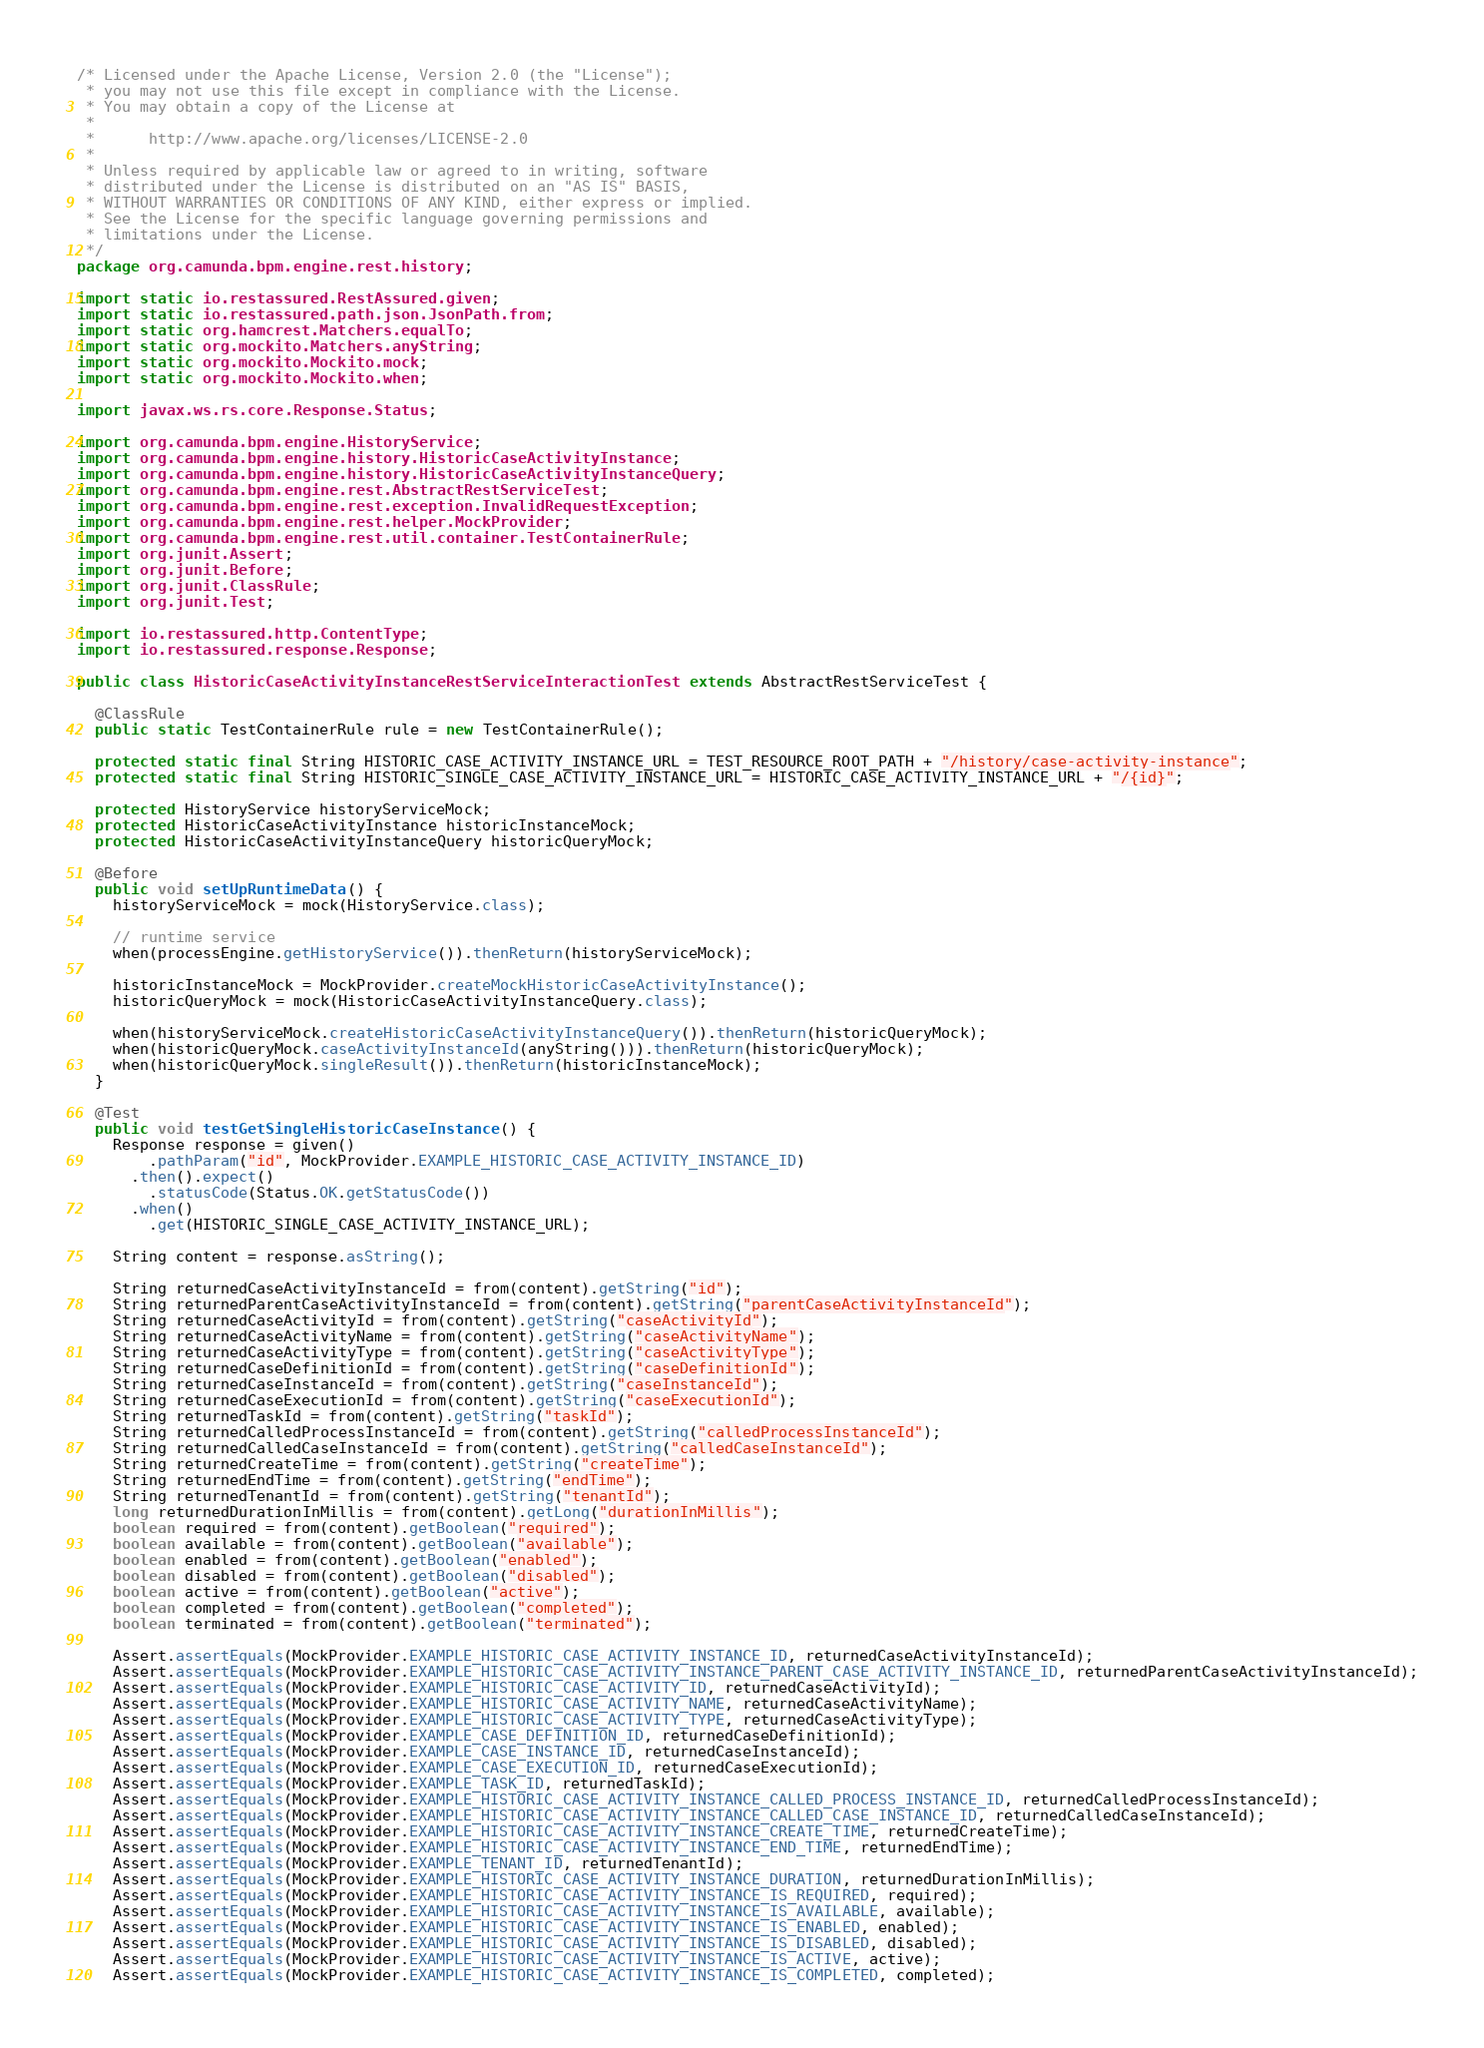<code> <loc_0><loc_0><loc_500><loc_500><_Java_>/* Licensed under the Apache License, Version 2.0 (the "License");
 * you may not use this file except in compliance with the License.
 * You may obtain a copy of the License at
 *
 *      http://www.apache.org/licenses/LICENSE-2.0
 *
 * Unless required by applicable law or agreed to in writing, software
 * distributed under the License is distributed on an "AS IS" BASIS,
 * WITHOUT WARRANTIES OR CONDITIONS OF ANY KIND, either express or implied.
 * See the License for the specific language governing permissions and
 * limitations under the License.
 */
package org.camunda.bpm.engine.rest.history;

import static io.restassured.RestAssured.given;
import static io.restassured.path.json.JsonPath.from;
import static org.hamcrest.Matchers.equalTo;
import static org.mockito.Matchers.anyString;
import static org.mockito.Mockito.mock;
import static org.mockito.Mockito.when;

import javax.ws.rs.core.Response.Status;

import org.camunda.bpm.engine.HistoryService;
import org.camunda.bpm.engine.history.HistoricCaseActivityInstance;
import org.camunda.bpm.engine.history.HistoricCaseActivityInstanceQuery;
import org.camunda.bpm.engine.rest.AbstractRestServiceTest;
import org.camunda.bpm.engine.rest.exception.InvalidRequestException;
import org.camunda.bpm.engine.rest.helper.MockProvider;
import org.camunda.bpm.engine.rest.util.container.TestContainerRule;
import org.junit.Assert;
import org.junit.Before;
import org.junit.ClassRule;
import org.junit.Test;

import io.restassured.http.ContentType;
import io.restassured.response.Response;

public class HistoricCaseActivityInstanceRestServiceInteractionTest extends AbstractRestServiceTest {

  @ClassRule
  public static TestContainerRule rule = new TestContainerRule();
  
  protected static final String HISTORIC_CASE_ACTIVITY_INSTANCE_URL = TEST_RESOURCE_ROOT_PATH + "/history/case-activity-instance";
  protected static final String HISTORIC_SINGLE_CASE_ACTIVITY_INSTANCE_URL = HISTORIC_CASE_ACTIVITY_INSTANCE_URL + "/{id}";

  protected HistoryService historyServiceMock;
  protected HistoricCaseActivityInstance historicInstanceMock;
  protected HistoricCaseActivityInstanceQuery historicQueryMock;

  @Before
  public void setUpRuntimeData() {
    historyServiceMock = mock(HistoryService.class);

    // runtime service
    when(processEngine.getHistoryService()).thenReturn(historyServiceMock);

    historicInstanceMock = MockProvider.createMockHistoricCaseActivityInstance();
    historicQueryMock = mock(HistoricCaseActivityInstanceQuery.class);

    when(historyServiceMock.createHistoricCaseActivityInstanceQuery()).thenReturn(historicQueryMock);
    when(historicQueryMock.caseActivityInstanceId(anyString())).thenReturn(historicQueryMock);
    when(historicQueryMock.singleResult()).thenReturn(historicInstanceMock);
  }

  @Test
  public void testGetSingleHistoricCaseInstance() {
    Response response = given()
        .pathParam("id", MockProvider.EXAMPLE_HISTORIC_CASE_ACTIVITY_INSTANCE_ID)
      .then().expect()
        .statusCode(Status.OK.getStatusCode())
      .when()
        .get(HISTORIC_SINGLE_CASE_ACTIVITY_INSTANCE_URL);

    String content = response.asString();

    String returnedCaseActivityInstanceId = from(content).getString("id");
    String returnedParentCaseActivityInstanceId = from(content).getString("parentCaseActivityInstanceId");
    String returnedCaseActivityId = from(content).getString("caseActivityId");
    String returnedCaseActivityName = from(content).getString("caseActivityName");
    String returnedCaseActivityType = from(content).getString("caseActivityType");
    String returnedCaseDefinitionId = from(content).getString("caseDefinitionId");
    String returnedCaseInstanceId = from(content).getString("caseInstanceId");
    String returnedCaseExecutionId = from(content).getString("caseExecutionId");
    String returnedTaskId = from(content).getString("taskId");
    String returnedCalledProcessInstanceId = from(content).getString("calledProcessInstanceId");
    String returnedCalledCaseInstanceId = from(content).getString("calledCaseInstanceId");
    String returnedCreateTime = from(content).getString("createTime");
    String returnedEndTime = from(content).getString("endTime");
    String returnedTenantId = from(content).getString("tenantId");
    long returnedDurationInMillis = from(content).getLong("durationInMillis");
    boolean required = from(content).getBoolean("required");
    boolean available = from(content).getBoolean("available");
    boolean enabled = from(content).getBoolean("enabled");
    boolean disabled = from(content).getBoolean("disabled");
    boolean active = from(content).getBoolean("active");
    boolean completed = from(content).getBoolean("completed");
    boolean terminated = from(content).getBoolean("terminated");

    Assert.assertEquals(MockProvider.EXAMPLE_HISTORIC_CASE_ACTIVITY_INSTANCE_ID, returnedCaseActivityInstanceId);
    Assert.assertEquals(MockProvider.EXAMPLE_HISTORIC_CASE_ACTIVITY_INSTANCE_PARENT_CASE_ACTIVITY_INSTANCE_ID, returnedParentCaseActivityInstanceId);
    Assert.assertEquals(MockProvider.EXAMPLE_HISTORIC_CASE_ACTIVITY_ID, returnedCaseActivityId);
    Assert.assertEquals(MockProvider.EXAMPLE_HISTORIC_CASE_ACTIVITY_NAME, returnedCaseActivityName);
    Assert.assertEquals(MockProvider.EXAMPLE_HISTORIC_CASE_ACTIVITY_TYPE, returnedCaseActivityType);
    Assert.assertEquals(MockProvider.EXAMPLE_CASE_DEFINITION_ID, returnedCaseDefinitionId);
    Assert.assertEquals(MockProvider.EXAMPLE_CASE_INSTANCE_ID, returnedCaseInstanceId);
    Assert.assertEquals(MockProvider.EXAMPLE_CASE_EXECUTION_ID, returnedCaseExecutionId);
    Assert.assertEquals(MockProvider.EXAMPLE_TASK_ID, returnedTaskId);
    Assert.assertEquals(MockProvider.EXAMPLE_HISTORIC_CASE_ACTIVITY_INSTANCE_CALLED_PROCESS_INSTANCE_ID, returnedCalledProcessInstanceId);
    Assert.assertEquals(MockProvider.EXAMPLE_HISTORIC_CASE_ACTIVITY_INSTANCE_CALLED_CASE_INSTANCE_ID, returnedCalledCaseInstanceId);
    Assert.assertEquals(MockProvider.EXAMPLE_HISTORIC_CASE_ACTIVITY_INSTANCE_CREATE_TIME, returnedCreateTime);
    Assert.assertEquals(MockProvider.EXAMPLE_HISTORIC_CASE_ACTIVITY_INSTANCE_END_TIME, returnedEndTime);
    Assert.assertEquals(MockProvider.EXAMPLE_TENANT_ID, returnedTenantId);
    Assert.assertEquals(MockProvider.EXAMPLE_HISTORIC_CASE_ACTIVITY_INSTANCE_DURATION, returnedDurationInMillis);
    Assert.assertEquals(MockProvider.EXAMPLE_HISTORIC_CASE_ACTIVITY_INSTANCE_IS_REQUIRED, required);
    Assert.assertEquals(MockProvider.EXAMPLE_HISTORIC_CASE_ACTIVITY_INSTANCE_IS_AVAILABLE, available);
    Assert.assertEquals(MockProvider.EXAMPLE_HISTORIC_CASE_ACTIVITY_INSTANCE_IS_ENABLED, enabled);
    Assert.assertEquals(MockProvider.EXAMPLE_HISTORIC_CASE_ACTIVITY_INSTANCE_IS_DISABLED, disabled);
    Assert.assertEquals(MockProvider.EXAMPLE_HISTORIC_CASE_ACTIVITY_INSTANCE_IS_ACTIVE, active);
    Assert.assertEquals(MockProvider.EXAMPLE_HISTORIC_CASE_ACTIVITY_INSTANCE_IS_COMPLETED, completed);</code> 